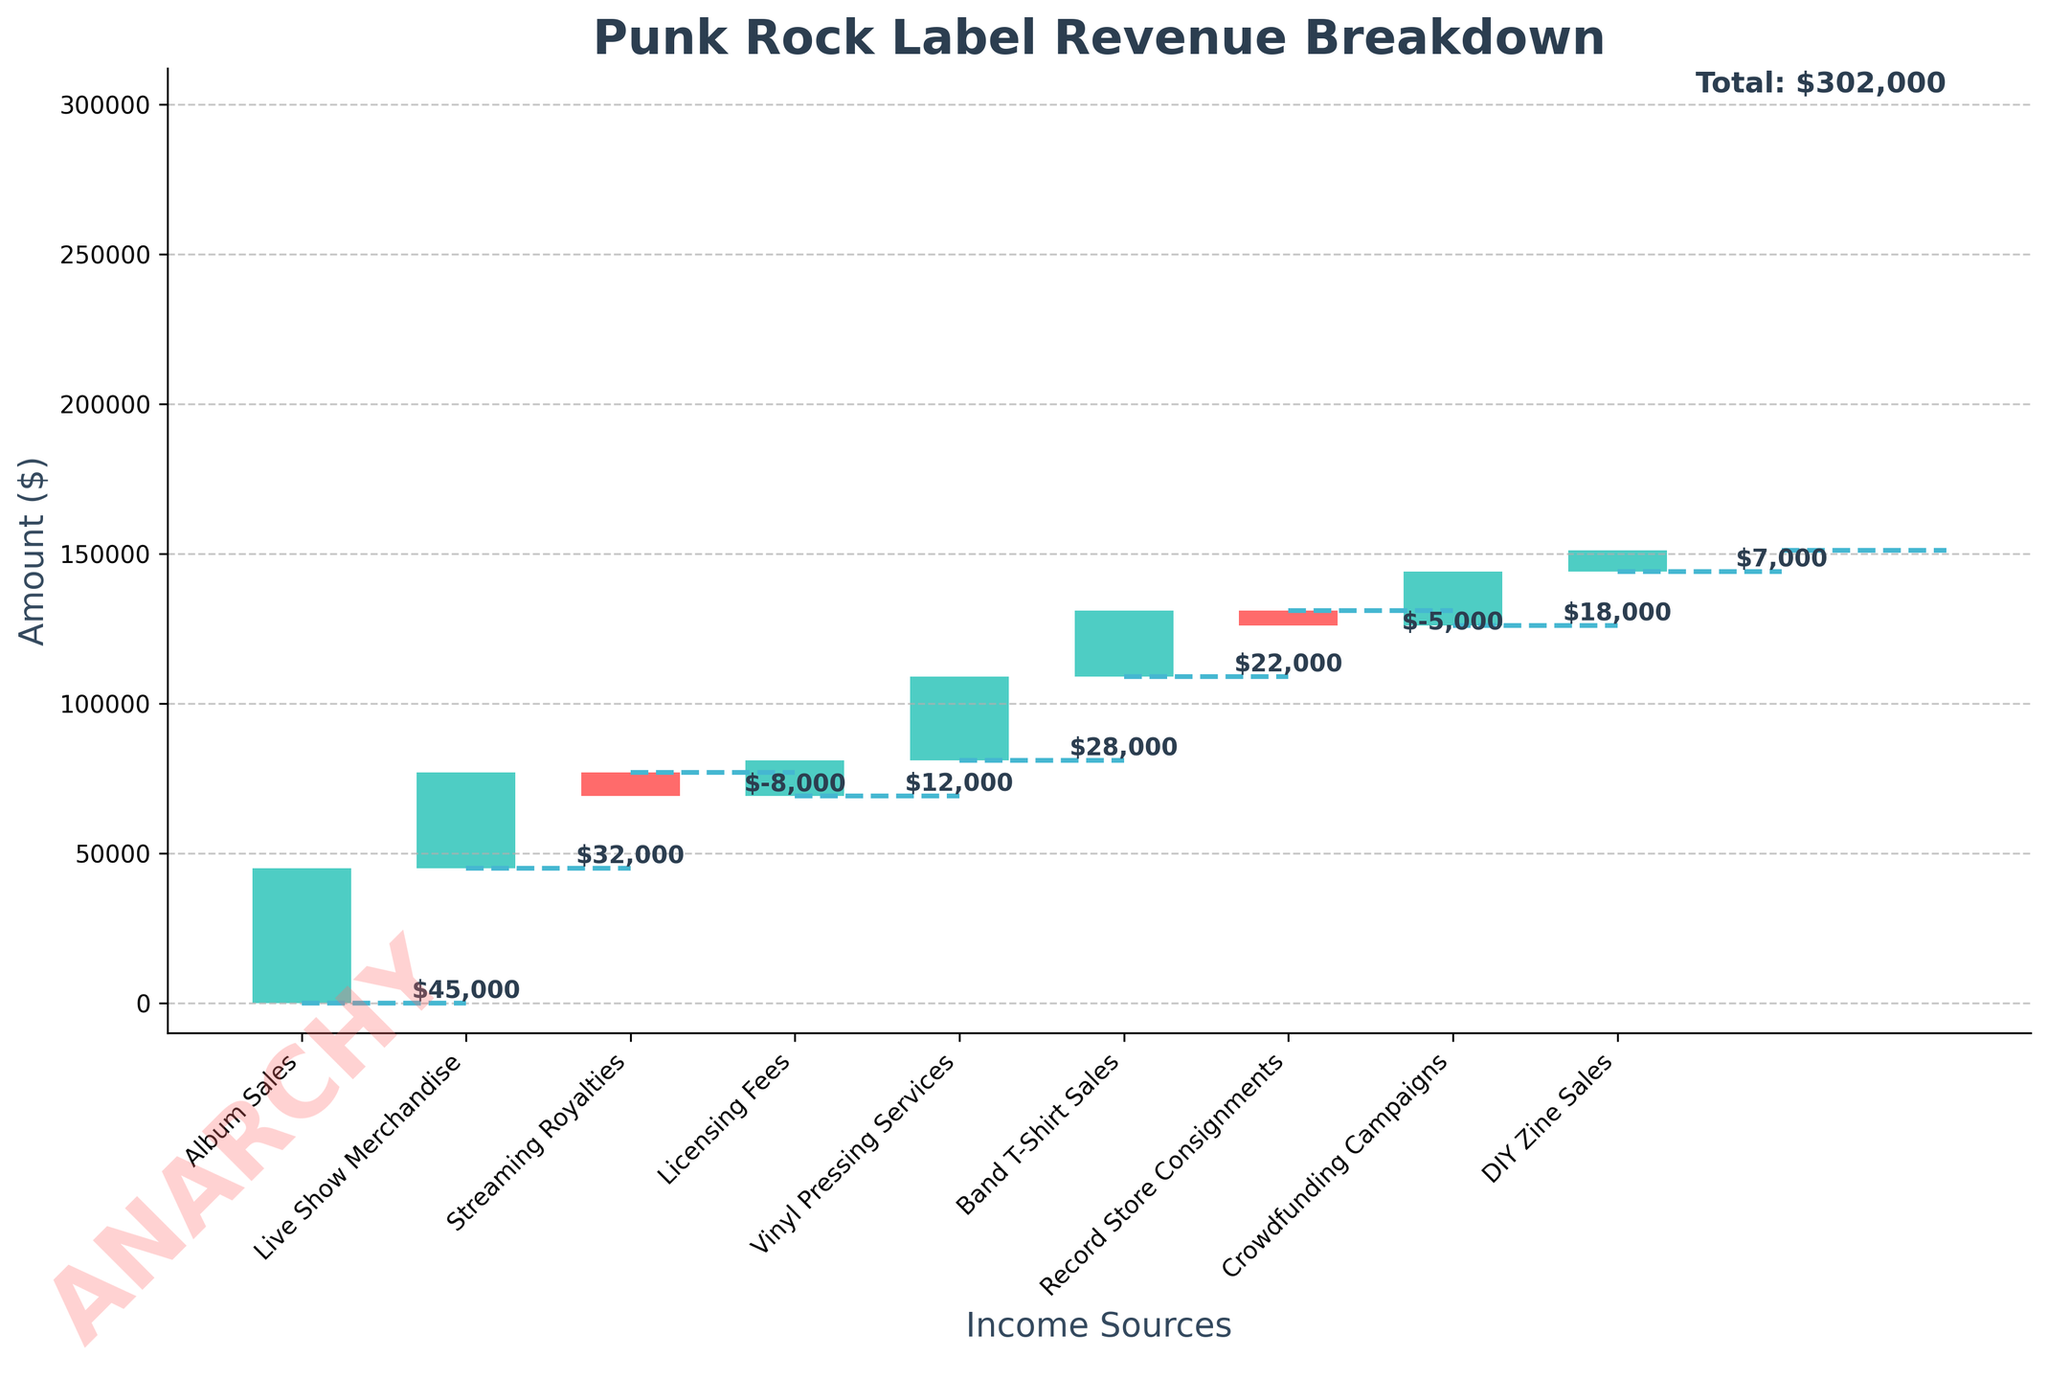What is the highest revenue source for the punk rock label? By looking at the height of each bar, Album Sales has the highest revenue, indicated by being the tallest green bar.
Answer: Album Sales Which revenue sources have negative values? There are two bars colored red which indicate negative values: Streaming Royalties and Record Store Consignments.
Answer: Streaming Royalties, Record Store Consignments What is the cumulative income after Live Show Merchandise? The first value (Album Sales) is $45,000 and the second value (Live Show Merchandise) adds $32,000. The cumulative income after these is $45,000 + $32,000 = $77,000.
Answer: $77,000 How does the income from Band T-Shirt Sales compare to Licensing Fees? Band T-Shirt Sales generates $22,000 which is higher than the $12,000 generated by Licensing Fees.
Answer: Higher What is the total income shown at the end of the chart? The chart shows a final cumulative total with the label 'End', which is $151,000.
Answer: $151,000 How much does the punk rock label lose from negative revenue sources combined? Combine the absolute values of negative numbers: $8,000 (Streaming Royalties) + $5,000 (Record Store Consignments) = $13,000.
Answer: $13,000 What are the revenue contributions from DIY Zine Sales and Crowdfunding Campaigns together? Sum of DIY Zine Sales ($7,000) and Crowdfunding Campaigns ($18,000) is $7,000 + $18,000 = $25,000.
Answer: $25,000 What income source has a lower revenue than Vinyl Pressing Services but higher than DIY Zine Sales? Looking at the heights of the bars, Band T-Shirt Sales ($22,000) fits this criterion, between Vinyl Pressing Services ($28,000) and DIY Zine Sales ($7,000).
Answer: Band T-Shirt Sales Does the chart include any non-revenue elements? The chart starts with 'Start' and ends with 'End', both of which are not revenue categories.
Answer: Yes 